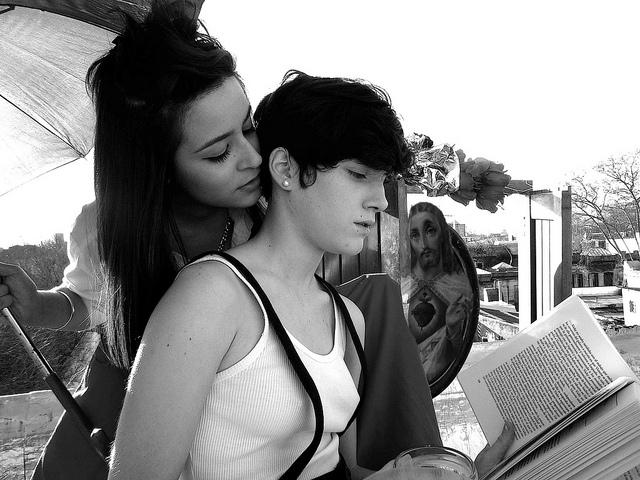What kind of flowers are near the woman's head?
Write a very short answer. Roses. What is the color of the girls' hair?
Give a very brief answer. Black. Do you see a picture of Jesus?
Quick response, please. Yes. 